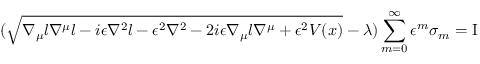<formula> <loc_0><loc_0><loc_500><loc_500>( \sqrt { \nabla _ { \mu } l \nabla ^ { \mu } l - i \epsilon \nabla ^ { 2 } l - \epsilon ^ { 2 } \nabla ^ { 2 } - 2 i \epsilon \nabla _ { \mu } l \nabla ^ { \mu } + \epsilon ^ { 2 } V ( x ) } - \lambda ) \sum _ { m = 0 } ^ { \infty } \epsilon ^ { m } \sigma _ { m } = I</formula> 